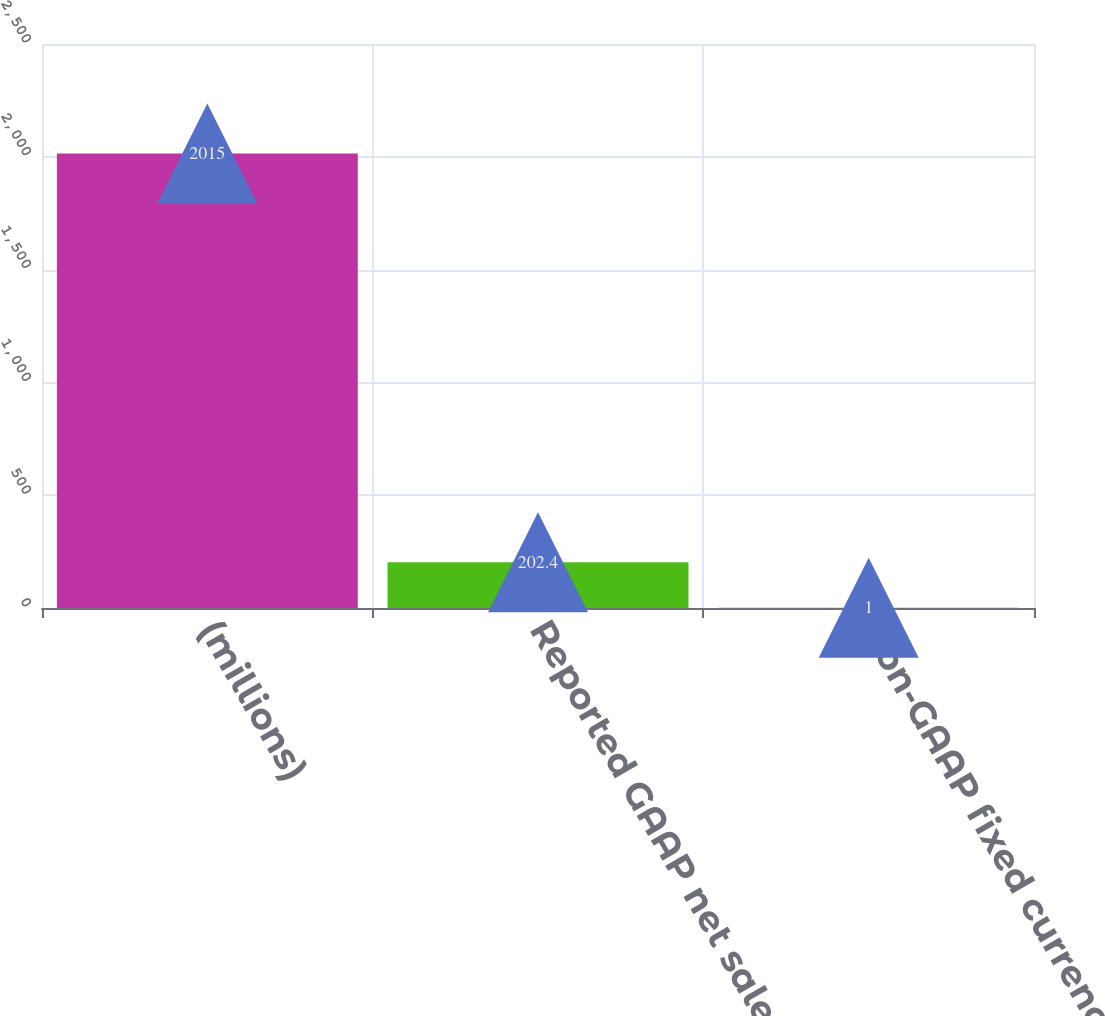Convert chart. <chart><loc_0><loc_0><loc_500><loc_500><bar_chart><fcel>(millions)<fcel>Reported GAAP net sales<fcel>Non-GAAP fixed currency sales<nl><fcel>2015<fcel>202.4<fcel>1<nl></chart> 